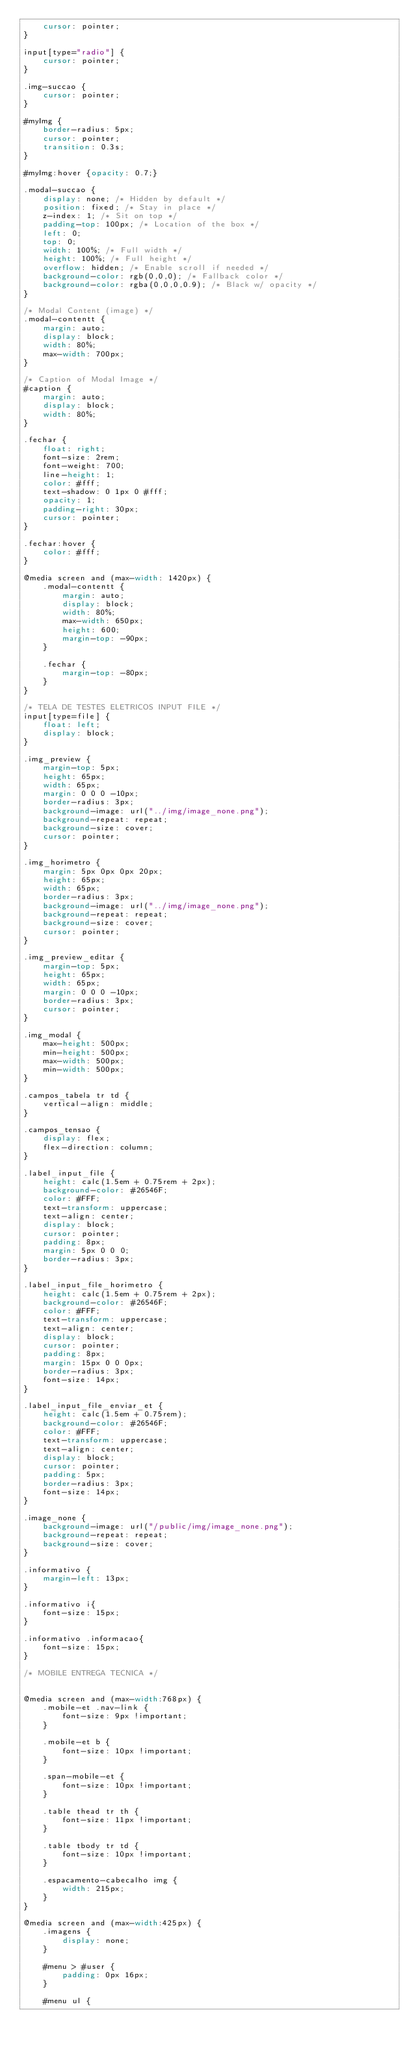Convert code to text. <code><loc_0><loc_0><loc_500><loc_500><_CSS_>    cursor: pointer;
}

input[type="radio"] {
    cursor: pointer;
}

.img-succao {
    cursor: pointer;
}

#myImg {
    border-radius: 5px;
    cursor: pointer;
    transition: 0.3s;
}

#myImg:hover {opacity: 0.7;}

.modal-succao {
    display: none; /* Hidden by default */
    position: fixed; /* Stay in place */
    z-index: 1; /* Sit on top */
    padding-top: 100px; /* Location of the box */
    left: 0;
    top: 0;
    width: 100%; /* Full width */
    height: 100%; /* Full height */
    overflow: hidden; /* Enable scroll if needed */
    background-color: rgb(0,0,0); /* Fallback color */
    background-color: rgba(0,0,0,0.9); /* Black w/ opacity */
}

/* Modal Content (image) */
.modal-contentt {
    margin: auto;
    display: block;
    width: 80%;
    max-width: 700px;
}

/* Caption of Modal Image */
#caption {
    margin: auto;
    display: block;
    width: 80%;
}

.fechar {
    float: right;
    font-size: 2rem;
    font-weight: 700;
    line-height: 1;
    color: #fff;
    text-shadow: 0 1px 0 #fff;
    opacity: 1;
    padding-right: 30px;
    cursor: pointer;
}

.fechar:hover {
    color: #fff;
}

@media screen and (max-width: 1420px) {
    .modal-contentt {
        margin: auto;
        display: block;
        width: 80%;
        max-width: 650px;
        height: 600;
        margin-top: -90px;
    }

    .fechar {        
        margin-top: -80px;
    }
}

/* TELA DE TESTES ELETRICOS INPUT FILE */
input[type=file] {
    float: left;
    display: block;
}

.img_preview {
    margin-top: 5px;
    height: 65px;
    width: 65px;
    margin: 0 0 0 -10px;
    border-radius: 3px;
    background-image: url("../img/image_none.png");
    background-repeat: repeat;
    background-size: cover;
    cursor: pointer;
}

.img_horimetro {
    margin: 5px 0px 0px 20px;
    height: 65px;
    width: 65px;
    border-radius: 3px;
    background-image: url("../img/image_none.png");
    background-repeat: repeat;
    background-size: cover;
    cursor: pointer;
}

.img_preview_editar {
    margin-top: 5px;
    height: 65px;
    width: 65px;
    margin: 0 0 0 -10px;
    border-radius: 3px;
    cursor: pointer;
}

.img_modal {
    max-height: 500px;
    min-height: 500px;
    max-width: 500px;
    min-width: 500px;
}

.campos_tabela tr td {
    vertical-align: middle;
}

.campos_tensao {
    display: flex;
    flex-direction: column;
}

.label_input_file {
    height: calc(1.5em + 0.75rem + 2px);
    background-color: #26546F;
    color: #FFF;
    text-transform: uppercase;
    text-align: center;
    display: block;
    cursor: pointer;
    padding: 8px;
    margin: 5px 0 0 0;
    border-radius: 3px;
}

.label_input_file_horimetro {
    height: calc(1.5em + 0.75rem + 2px);
    background-color: #26546F;
    color: #FFF;
    text-transform: uppercase;
    text-align: center;
    display: block;
    cursor: pointer;
    padding: 8px;
    margin: 15px 0 0 0px;
    border-radius: 3px;
    font-size: 14px;
}

.label_input_file_enviar_et {
    height: calc(1.5em + 0.75rem);
    background-color: #26546F;
    color: #FFF;
    text-transform: uppercase;
    text-align: center;
    display: block;
    cursor: pointer;
    padding: 5px;
    border-radius: 3px;
    font-size: 14px;
}

.image_none {
    background-image: url("/public/img/image_none.png");
    background-repeat: repeat;
    background-size: cover;
}

.informativo {
    margin-left: 13px;
}

.informativo i{
    font-size: 15px;
}

.informativo .informacao{
    font-size: 15px;
}

/* MOBILE ENTREGA TECNICA */


@media screen and (max-width:768px) {    
    .mobile-et .nav-link {
        font-size: 9px !important;
    }

    .mobile-et b {
        font-size: 10px !important;
    }

    .span-mobile-et {
        font-size: 10px !important;
    }

    .table thead tr th {
        font-size: 11px !important;
    }

    .table tbody tr td {
        font-size: 10px !important;
    }
    
    .espacamento-cabecalho img {
        width: 215px;
    }
}

@media screen and (max-width:425px) {
    .imagens {
        display: none;
    }

    #menu > #user {
        padding: 0px 16px;
    }

    #menu ul {</code> 